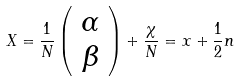Convert formula to latex. <formula><loc_0><loc_0><loc_500><loc_500>X = \frac { 1 } { N } \left ( \begin{array} { c } \alpha \\ \beta \end{array} \right ) + \frac { \chi } { N } = x + \frac { 1 } { 2 } { n }</formula> 